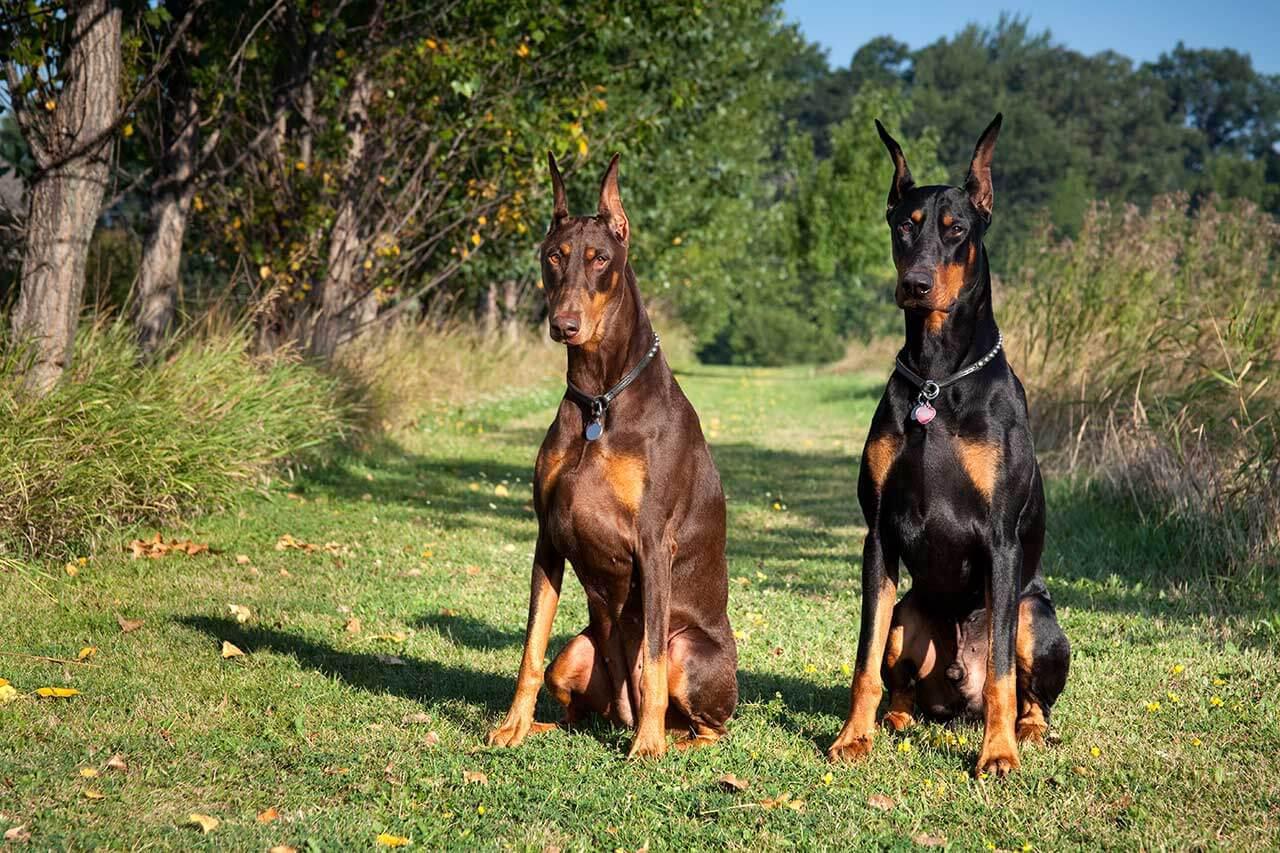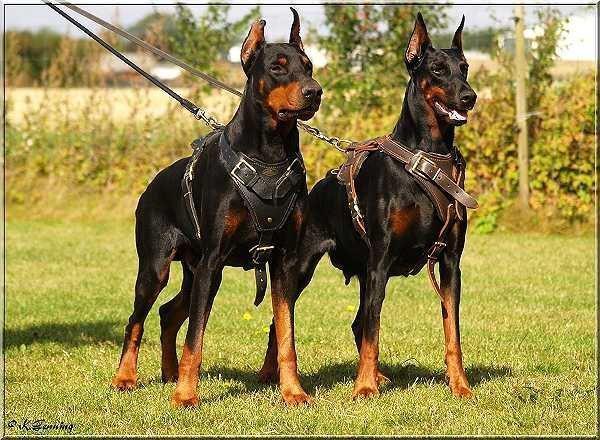The first image is the image on the left, the second image is the image on the right. For the images shown, is this caption "Two dogs are sitting in the grass in the image on the left, while two lie in the grass in the image on the right." true? Answer yes or no. No. The first image is the image on the left, the second image is the image on the right. Examine the images to the left and right. Is the description "Every image shows exactly two dogs wearing collars, and no dog is actively hooked up to a leash." accurate? Answer yes or no. No. 